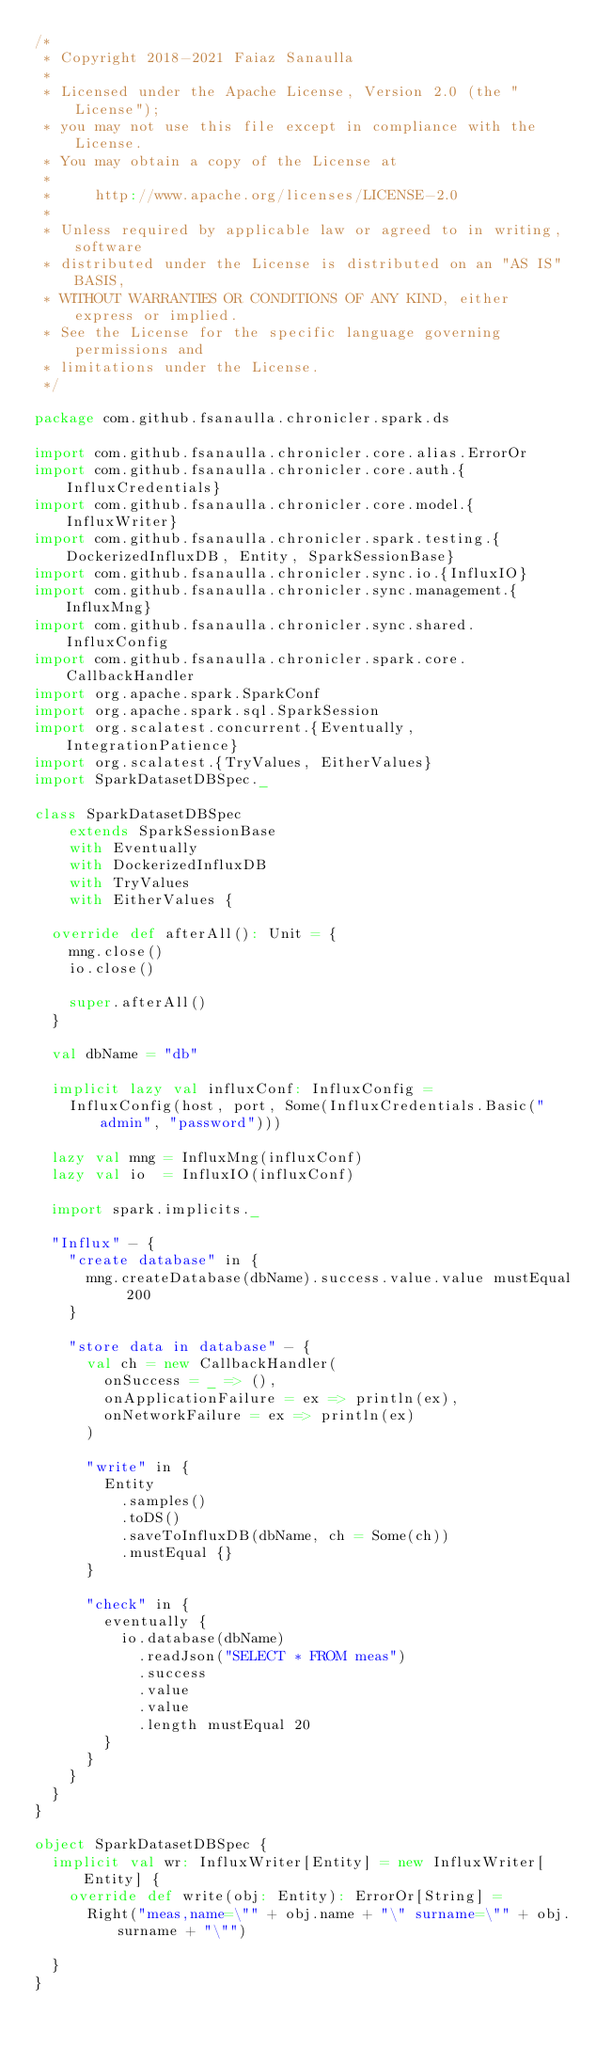Convert code to text. <code><loc_0><loc_0><loc_500><loc_500><_Scala_>/*
 * Copyright 2018-2021 Faiaz Sanaulla
 *
 * Licensed under the Apache License, Version 2.0 (the "License");
 * you may not use this file except in compliance with the License.
 * You may obtain a copy of the License at
 *
 *     http://www.apache.org/licenses/LICENSE-2.0
 *
 * Unless required by applicable law or agreed to in writing, software
 * distributed under the License is distributed on an "AS IS" BASIS,
 * WITHOUT WARRANTIES OR CONDITIONS OF ANY KIND, either express or implied.
 * See the License for the specific language governing permissions and
 * limitations under the License.
 */

package com.github.fsanaulla.chronicler.spark.ds

import com.github.fsanaulla.chronicler.core.alias.ErrorOr
import com.github.fsanaulla.chronicler.core.auth.{InfluxCredentials}
import com.github.fsanaulla.chronicler.core.model.{InfluxWriter}
import com.github.fsanaulla.chronicler.spark.testing.{DockerizedInfluxDB, Entity, SparkSessionBase}
import com.github.fsanaulla.chronicler.sync.io.{InfluxIO}
import com.github.fsanaulla.chronicler.sync.management.{InfluxMng}
import com.github.fsanaulla.chronicler.sync.shared.InfluxConfig
import com.github.fsanaulla.chronicler.spark.core.CallbackHandler
import org.apache.spark.SparkConf
import org.apache.spark.sql.SparkSession
import org.scalatest.concurrent.{Eventually, IntegrationPatience}
import org.scalatest.{TryValues, EitherValues}
import SparkDatasetDBSpec._

class SparkDatasetDBSpec
    extends SparkSessionBase
    with Eventually
    with DockerizedInfluxDB
    with TryValues
    with EitherValues {

  override def afterAll(): Unit = {
    mng.close()
    io.close()

    super.afterAll()
  }

  val dbName = "db"

  implicit lazy val influxConf: InfluxConfig =
    InfluxConfig(host, port, Some(InfluxCredentials.Basic("admin", "password")))

  lazy val mng = InfluxMng(influxConf)
  lazy val io  = InfluxIO(influxConf)

  import spark.implicits._

  "Influx" - {
    "create database" in {
      mng.createDatabase(dbName).success.value.value mustEqual 200
    }

    "store data in database" - {
      val ch = new CallbackHandler(
        onSuccess = _ => (),
        onApplicationFailure = ex => println(ex),
        onNetworkFailure = ex => println(ex)
      )

      "write" in {
        Entity
          .samples()
          .toDS()
          .saveToInfluxDB(dbName, ch = Some(ch))
          .mustEqual {}
      }

      "check" in {
        eventually {
          io.database(dbName)
            .readJson("SELECT * FROM meas")
            .success
            .value
            .value
            .length mustEqual 20
        }
      }
    }
  }
}

object SparkDatasetDBSpec {
  implicit val wr: InfluxWriter[Entity] = new InfluxWriter[Entity] {
    override def write(obj: Entity): ErrorOr[String] =
      Right("meas,name=\"" + obj.name + "\" surname=\"" + obj.surname + "\"")

  }
}
</code> 